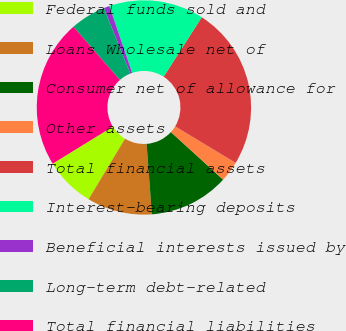<chart> <loc_0><loc_0><loc_500><loc_500><pie_chart><fcel>Federal funds sold and<fcel>Loans Wholesale net of<fcel>Consumer net of allowance for<fcel>Other assets<fcel>Total financial assets<fcel>Interest-bearing deposits<fcel>Beneficial interests issued by<fcel>Long-term debt-related<fcel>Total financial liabilities<nl><fcel>7.58%<fcel>9.82%<fcel>12.06%<fcel>3.11%<fcel>24.58%<fcel>14.3%<fcel>0.87%<fcel>5.34%<fcel>22.35%<nl></chart> 